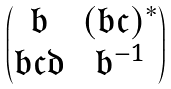Convert formula to latex. <formula><loc_0><loc_0><loc_500><loc_500>\begin{pmatrix} \mathfrak { b } & ( \mathfrak { b c } ) ^ { * } \\ \mathfrak { b c d } & \mathfrak { b } ^ { - 1 } \end{pmatrix}</formula> 